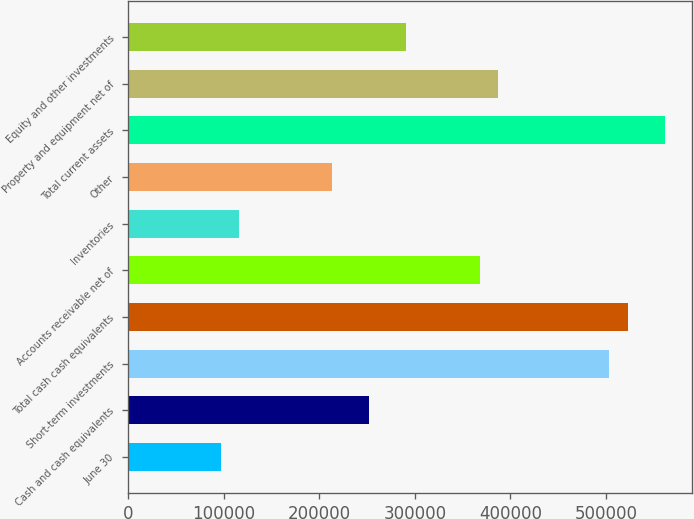<chart> <loc_0><loc_0><loc_500><loc_500><bar_chart><fcel>June 30<fcel>Cash and cash equivalents<fcel>Short-term investments<fcel>Total cash cash equivalents<fcel>Accounts receivable net of<fcel>Inventories<fcel>Other<fcel>Total current assets<fcel>Property and equipment net of<fcel>Equity and other investments<nl><fcel>96847.2<fcel>251802<fcel>503604<fcel>522973<fcel>368018<fcel>116217<fcel>213063<fcel>561712<fcel>387388<fcel>290541<nl></chart> 